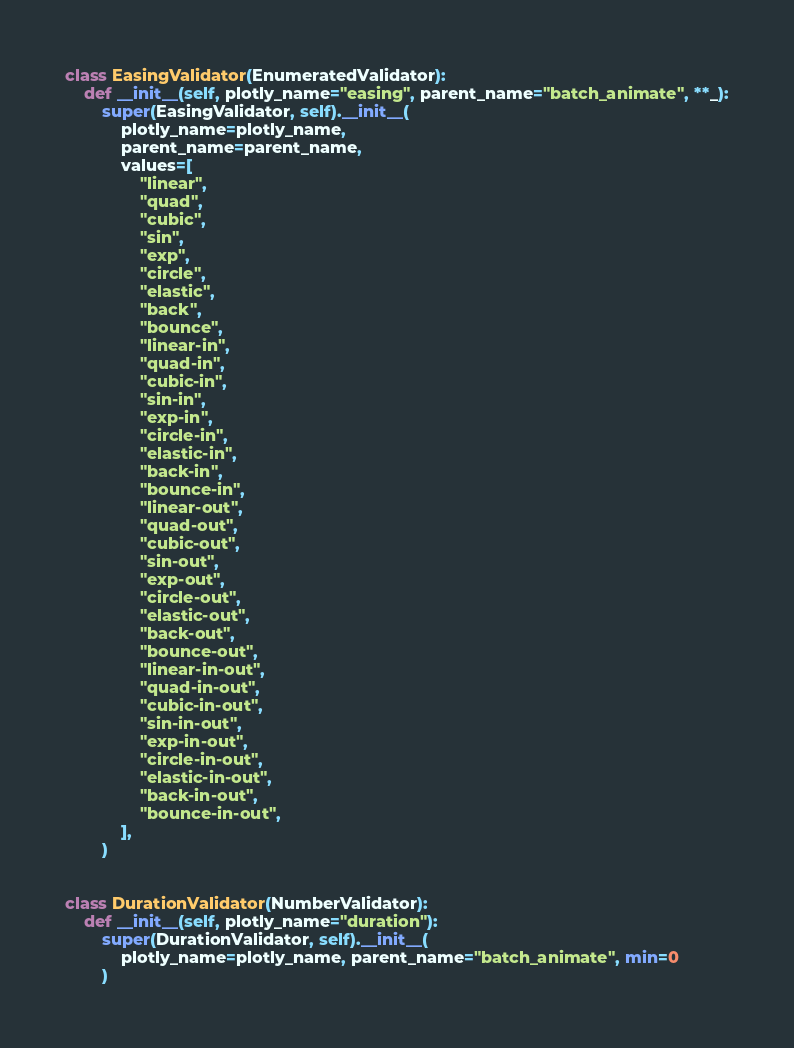<code> <loc_0><loc_0><loc_500><loc_500><_Python_>

class EasingValidator(EnumeratedValidator):
    def __init__(self, plotly_name="easing", parent_name="batch_animate", **_):
        super(EasingValidator, self).__init__(
            plotly_name=plotly_name,
            parent_name=parent_name,
            values=[
                "linear",
                "quad",
                "cubic",
                "sin",
                "exp",
                "circle",
                "elastic",
                "back",
                "bounce",
                "linear-in",
                "quad-in",
                "cubic-in",
                "sin-in",
                "exp-in",
                "circle-in",
                "elastic-in",
                "back-in",
                "bounce-in",
                "linear-out",
                "quad-out",
                "cubic-out",
                "sin-out",
                "exp-out",
                "circle-out",
                "elastic-out",
                "back-out",
                "bounce-out",
                "linear-in-out",
                "quad-in-out",
                "cubic-in-out",
                "sin-in-out",
                "exp-in-out",
                "circle-in-out",
                "elastic-in-out",
                "back-in-out",
                "bounce-in-out",
            ],
        )


class DurationValidator(NumberValidator):
    def __init__(self, plotly_name="duration"):
        super(DurationValidator, self).__init__(
            plotly_name=plotly_name, parent_name="batch_animate", min=0
        )
</code> 